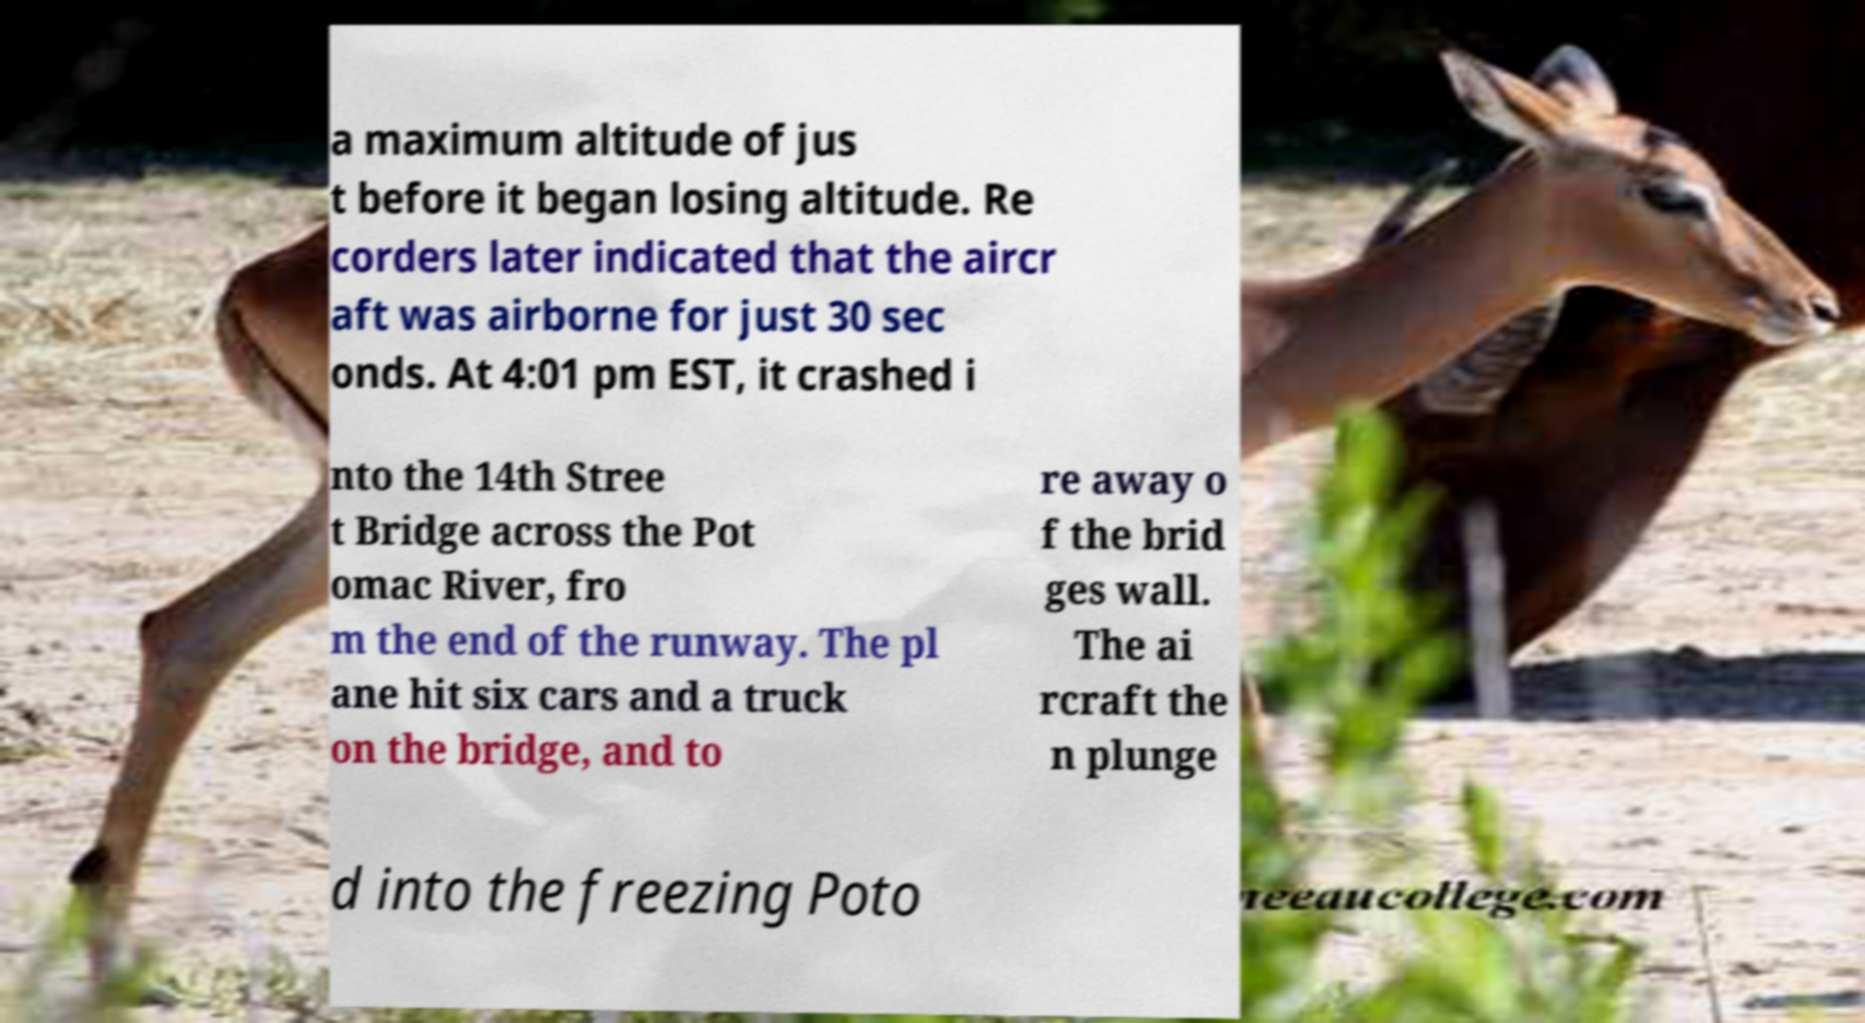Can you accurately transcribe the text from the provided image for me? a maximum altitude of jus t before it began losing altitude. Re corders later indicated that the aircr aft was airborne for just 30 sec onds. At 4:01 pm EST, it crashed i nto the 14th Stree t Bridge across the Pot omac River, fro m the end of the runway. The pl ane hit six cars and a truck on the bridge, and to re away o f the brid ges wall. The ai rcraft the n plunge d into the freezing Poto 